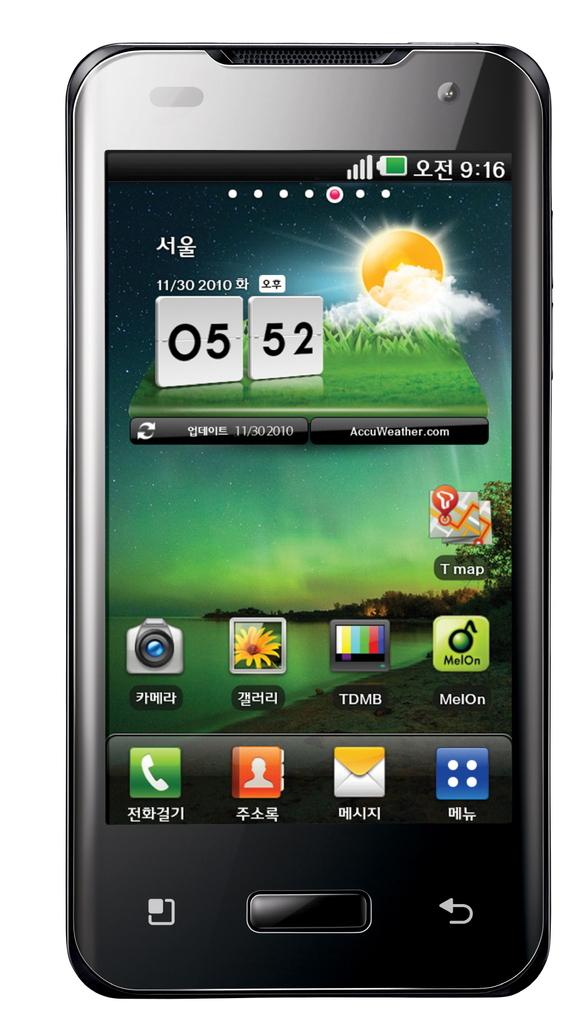What time is it?
Keep it short and to the point. 5:52. 